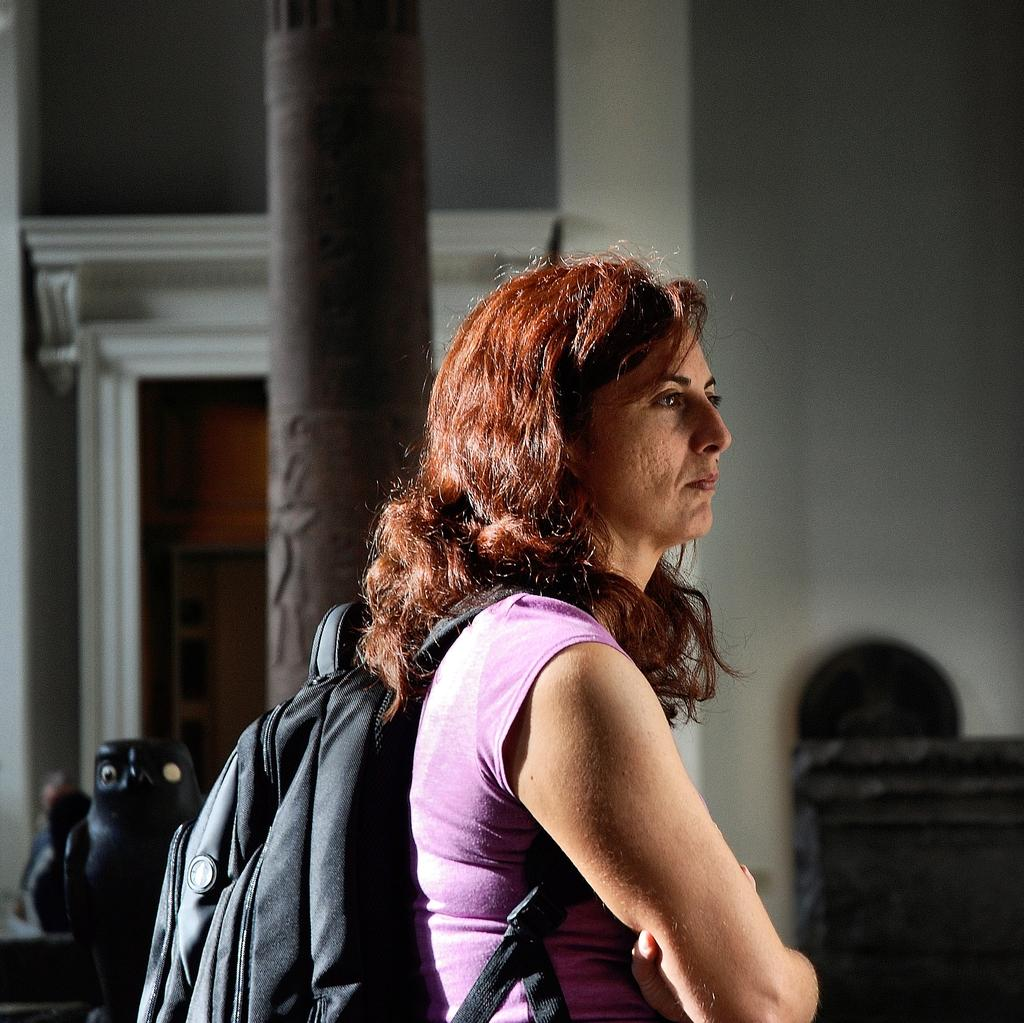Who is the main subject in the image? There is a woman in the image. What is the woman wearing on her upper body? The woman is wearing a pink t-shirt. What accessory is the woman carrying in the image? The woman is wearing a black bag. What is the color of the woman's hair? The woman has red hair. What architectural feature can be seen behind the woman? There is a pillar behind the woman. What can be seen in the background of the image? There is a door visible in the background. What type of religion does the woman practice, as indicated by the symbols on her t-shirt? There are no religious symbols visible on the woman's pink t-shirt in the image. How many sisters does the woman have, as indicated by the number of people in the image? The image only shows one woman, so it cannot be determined how many sisters she has. 